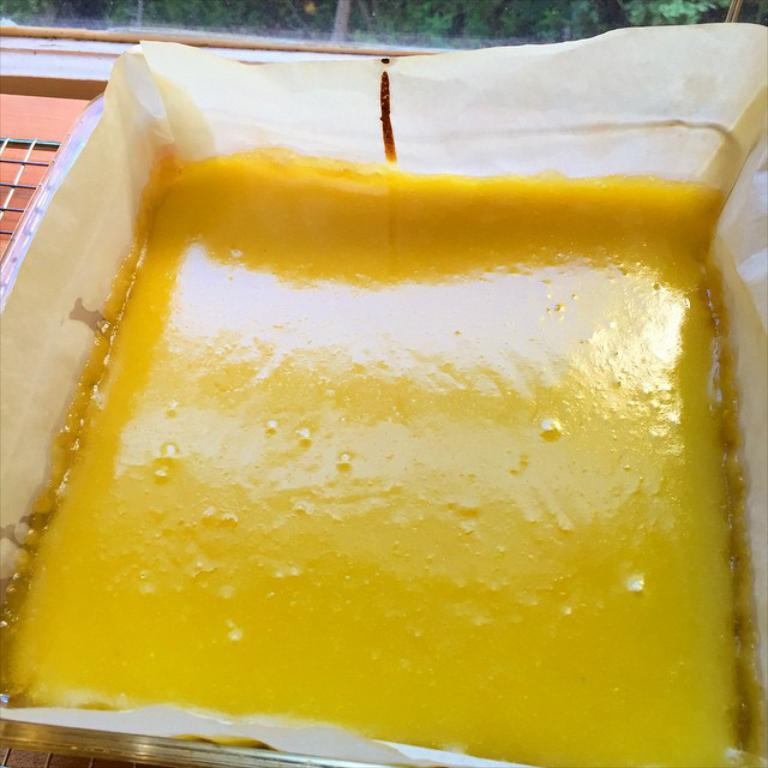What type of liquid is in the container in the image? There is a thick liquid in the container in the image. What color is the liquid? The liquid is yellow in color. Where is the container placed? The container is placed on a grill. What can be seen at the top of the image? Green leaves are visible at the top of the image. What type of home can be seen in the background of the image? There is no home visible in the image; it only shows a container with a thick yellow liquid, a grill, and green leaves at the top. What type of juice is being offered in the image? There is no juice being offered in the image; it only shows a container with a thick yellow liquid. 